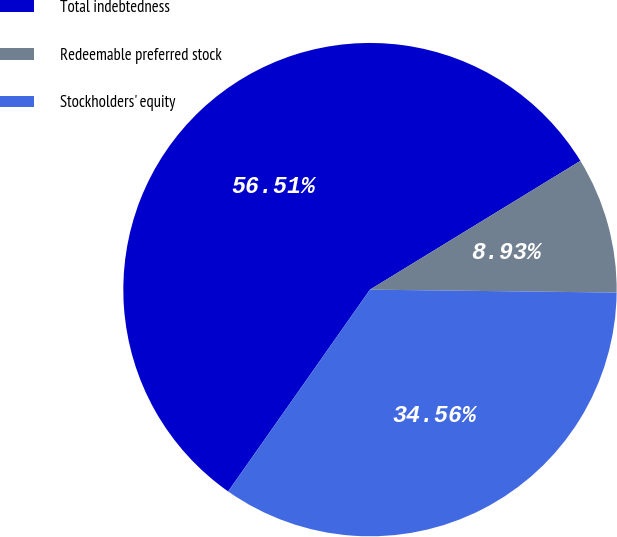Convert chart to OTSL. <chart><loc_0><loc_0><loc_500><loc_500><pie_chart><fcel>Total indebtedness<fcel>Redeemable preferred stock<fcel>Stockholders' equity<nl><fcel>56.51%<fcel>8.93%<fcel>34.56%<nl></chart> 